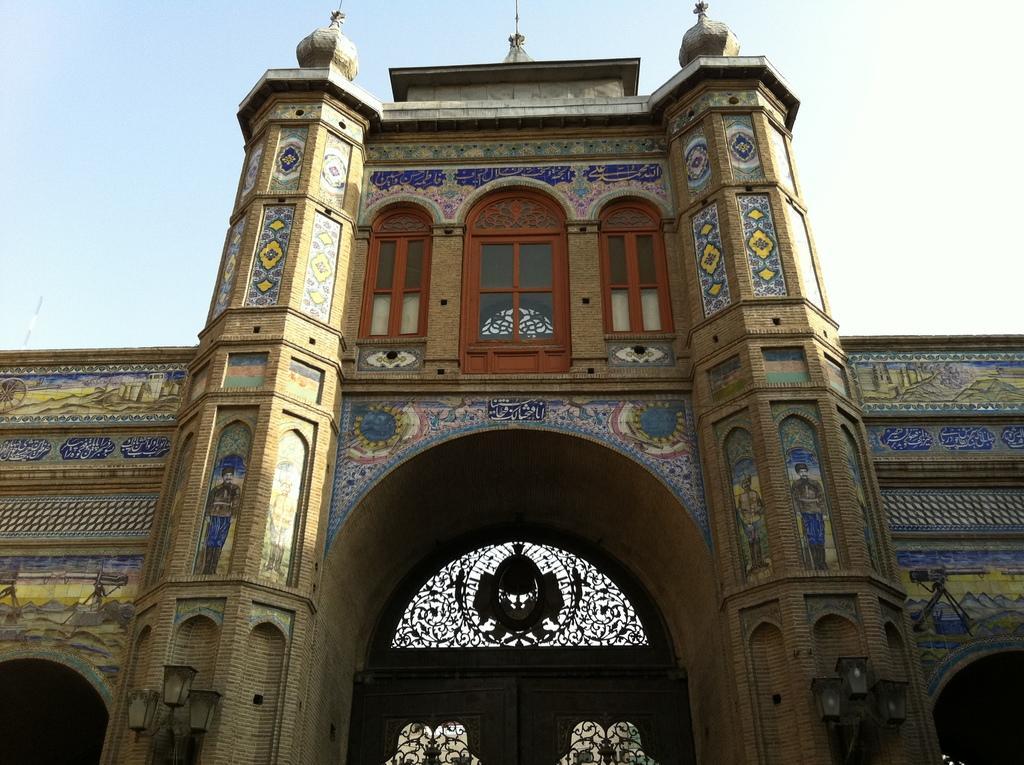Can you describe this image briefly? In the center of the image, we can see a building and at the top, there is sky. 